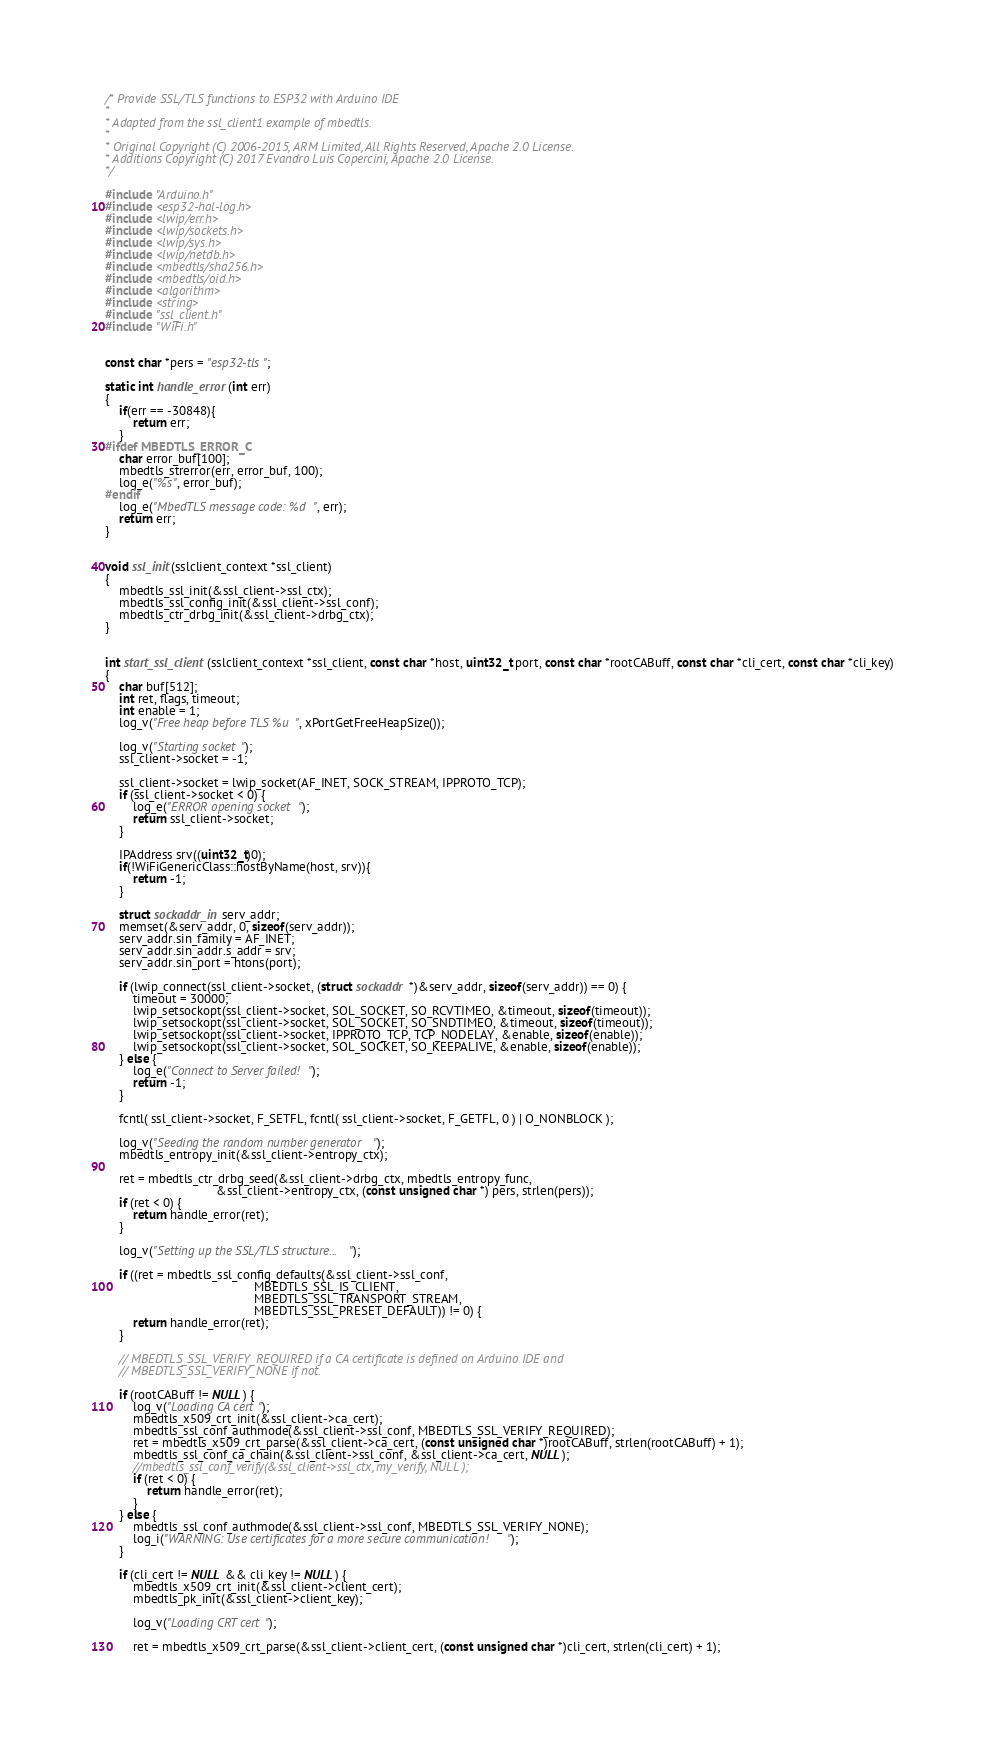Convert code to text. <code><loc_0><loc_0><loc_500><loc_500><_C++_>/* Provide SSL/TLS functions to ESP32 with Arduino IDE
*
* Adapted from the ssl_client1 example of mbedtls.
*
* Original Copyright (C) 2006-2015, ARM Limited, All Rights Reserved, Apache 2.0 License.
* Additions Copyright (C) 2017 Evandro Luis Copercini, Apache 2.0 License.
*/

#include "Arduino.h"
#include <esp32-hal-log.h>
#include <lwip/err.h>
#include <lwip/sockets.h>
#include <lwip/sys.h>
#include <lwip/netdb.h>
#include <mbedtls/sha256.h>
#include <mbedtls/oid.h>
#include <algorithm>
#include <string>
#include "ssl_client.h"
#include "WiFi.h"


const char *pers = "esp32-tls";

static int handle_error(int err)
{
    if(err == -30848){
        return err;
    }
#ifdef MBEDTLS_ERROR_C
    char error_buf[100];
    mbedtls_strerror(err, error_buf, 100);
    log_e("%s", error_buf);
#endif
    log_e("MbedTLS message code: %d", err);
    return err;
}


void ssl_init(sslclient_context *ssl_client)
{
    mbedtls_ssl_init(&ssl_client->ssl_ctx);
    mbedtls_ssl_config_init(&ssl_client->ssl_conf);
    mbedtls_ctr_drbg_init(&ssl_client->drbg_ctx);
}


int start_ssl_client(sslclient_context *ssl_client, const char *host, uint32_t port, const char *rootCABuff, const char *cli_cert, const char *cli_key)
{
    char buf[512];
    int ret, flags, timeout;
    int enable = 1;
    log_v("Free heap before TLS %u", xPortGetFreeHeapSize());

    log_v("Starting socket");
    ssl_client->socket = -1;

    ssl_client->socket = lwip_socket(AF_INET, SOCK_STREAM, IPPROTO_TCP);
    if (ssl_client->socket < 0) {
        log_e("ERROR opening socket");
        return ssl_client->socket;
    }

    IPAddress srv((uint32_t)0);
    if(!WiFiGenericClass::hostByName(host, srv)){
        return -1;
    }

    struct sockaddr_in serv_addr;
    memset(&serv_addr, 0, sizeof(serv_addr));
    serv_addr.sin_family = AF_INET;
    serv_addr.sin_addr.s_addr = srv;
    serv_addr.sin_port = htons(port);

    if (lwip_connect(ssl_client->socket, (struct sockaddr *)&serv_addr, sizeof(serv_addr)) == 0) {
        timeout = 30000;
        lwip_setsockopt(ssl_client->socket, SOL_SOCKET, SO_RCVTIMEO, &timeout, sizeof(timeout));
        lwip_setsockopt(ssl_client->socket, SOL_SOCKET, SO_SNDTIMEO, &timeout, sizeof(timeout));
        lwip_setsockopt(ssl_client->socket, IPPROTO_TCP, TCP_NODELAY, &enable, sizeof(enable));
        lwip_setsockopt(ssl_client->socket, SOL_SOCKET, SO_KEEPALIVE, &enable, sizeof(enable));
    } else {
        log_e("Connect to Server failed!");
        return -1;
    }

    fcntl( ssl_client->socket, F_SETFL, fcntl( ssl_client->socket, F_GETFL, 0 ) | O_NONBLOCK );

    log_v("Seeding the random number generator");
    mbedtls_entropy_init(&ssl_client->entropy_ctx);

    ret = mbedtls_ctr_drbg_seed(&ssl_client->drbg_ctx, mbedtls_entropy_func,
                                &ssl_client->entropy_ctx, (const unsigned char *) pers, strlen(pers));
    if (ret < 0) {
        return handle_error(ret);
    }

    log_v("Setting up the SSL/TLS structure...");

    if ((ret = mbedtls_ssl_config_defaults(&ssl_client->ssl_conf,
                                           MBEDTLS_SSL_IS_CLIENT,
                                           MBEDTLS_SSL_TRANSPORT_STREAM,
                                           MBEDTLS_SSL_PRESET_DEFAULT)) != 0) {
        return handle_error(ret);
    }

    // MBEDTLS_SSL_VERIFY_REQUIRED if a CA certificate is defined on Arduino IDE and
    // MBEDTLS_SSL_VERIFY_NONE if not.

    if (rootCABuff != NULL) {
        log_v("Loading CA cert");
        mbedtls_x509_crt_init(&ssl_client->ca_cert);
        mbedtls_ssl_conf_authmode(&ssl_client->ssl_conf, MBEDTLS_SSL_VERIFY_REQUIRED);
        ret = mbedtls_x509_crt_parse(&ssl_client->ca_cert, (const unsigned char *)rootCABuff, strlen(rootCABuff) + 1);
        mbedtls_ssl_conf_ca_chain(&ssl_client->ssl_conf, &ssl_client->ca_cert, NULL);
        //mbedtls_ssl_conf_verify(&ssl_client->ssl_ctx, my_verify, NULL );
        if (ret < 0) {
            return handle_error(ret);
        }
    } else {
        mbedtls_ssl_conf_authmode(&ssl_client->ssl_conf, MBEDTLS_SSL_VERIFY_NONE);
        log_i("WARNING: Use certificates for a more secure communication!");
    }

    if (cli_cert != NULL && cli_key != NULL) {
        mbedtls_x509_crt_init(&ssl_client->client_cert);
        mbedtls_pk_init(&ssl_client->client_key);

        log_v("Loading CRT cert");

        ret = mbedtls_x509_crt_parse(&ssl_client->client_cert, (const unsigned char *)cli_cert, strlen(cli_cert) + 1);</code> 